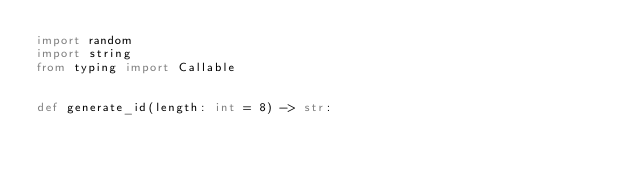Convert code to text. <code><loc_0><loc_0><loc_500><loc_500><_Python_>import random
import string
from typing import Callable


def generate_id(length: int = 8) -> str:</code> 